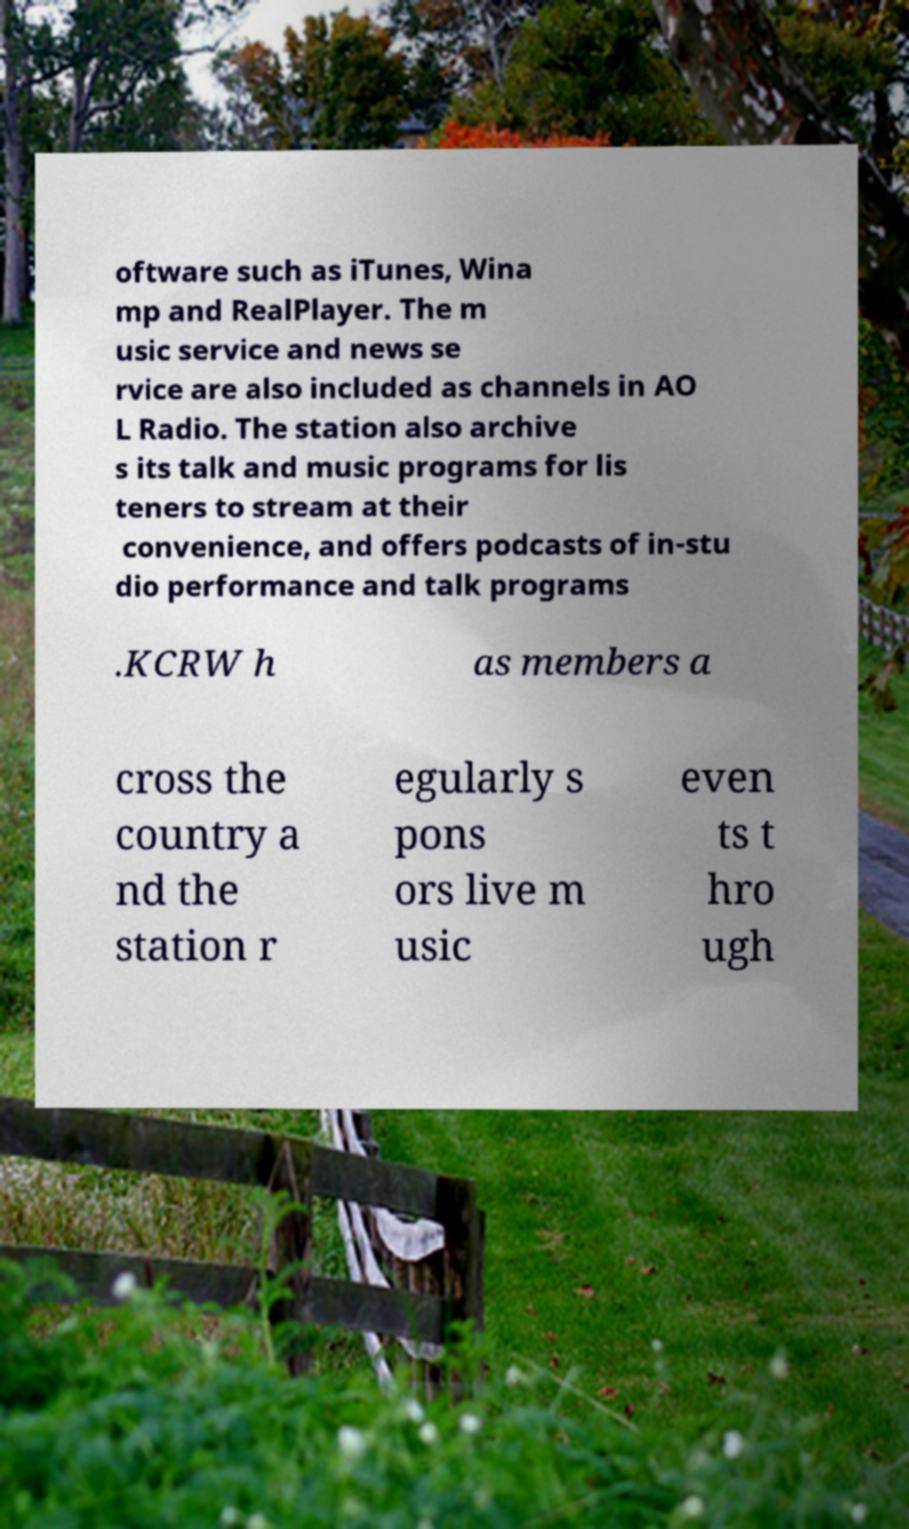Can you read and provide the text displayed in the image?This photo seems to have some interesting text. Can you extract and type it out for me? oftware such as iTunes, Wina mp and RealPlayer. The m usic service and news se rvice are also included as channels in AO L Radio. The station also archive s its talk and music programs for lis teners to stream at their convenience, and offers podcasts of in-stu dio performance and talk programs .KCRW h as members a cross the country a nd the station r egularly s pons ors live m usic even ts t hro ugh 